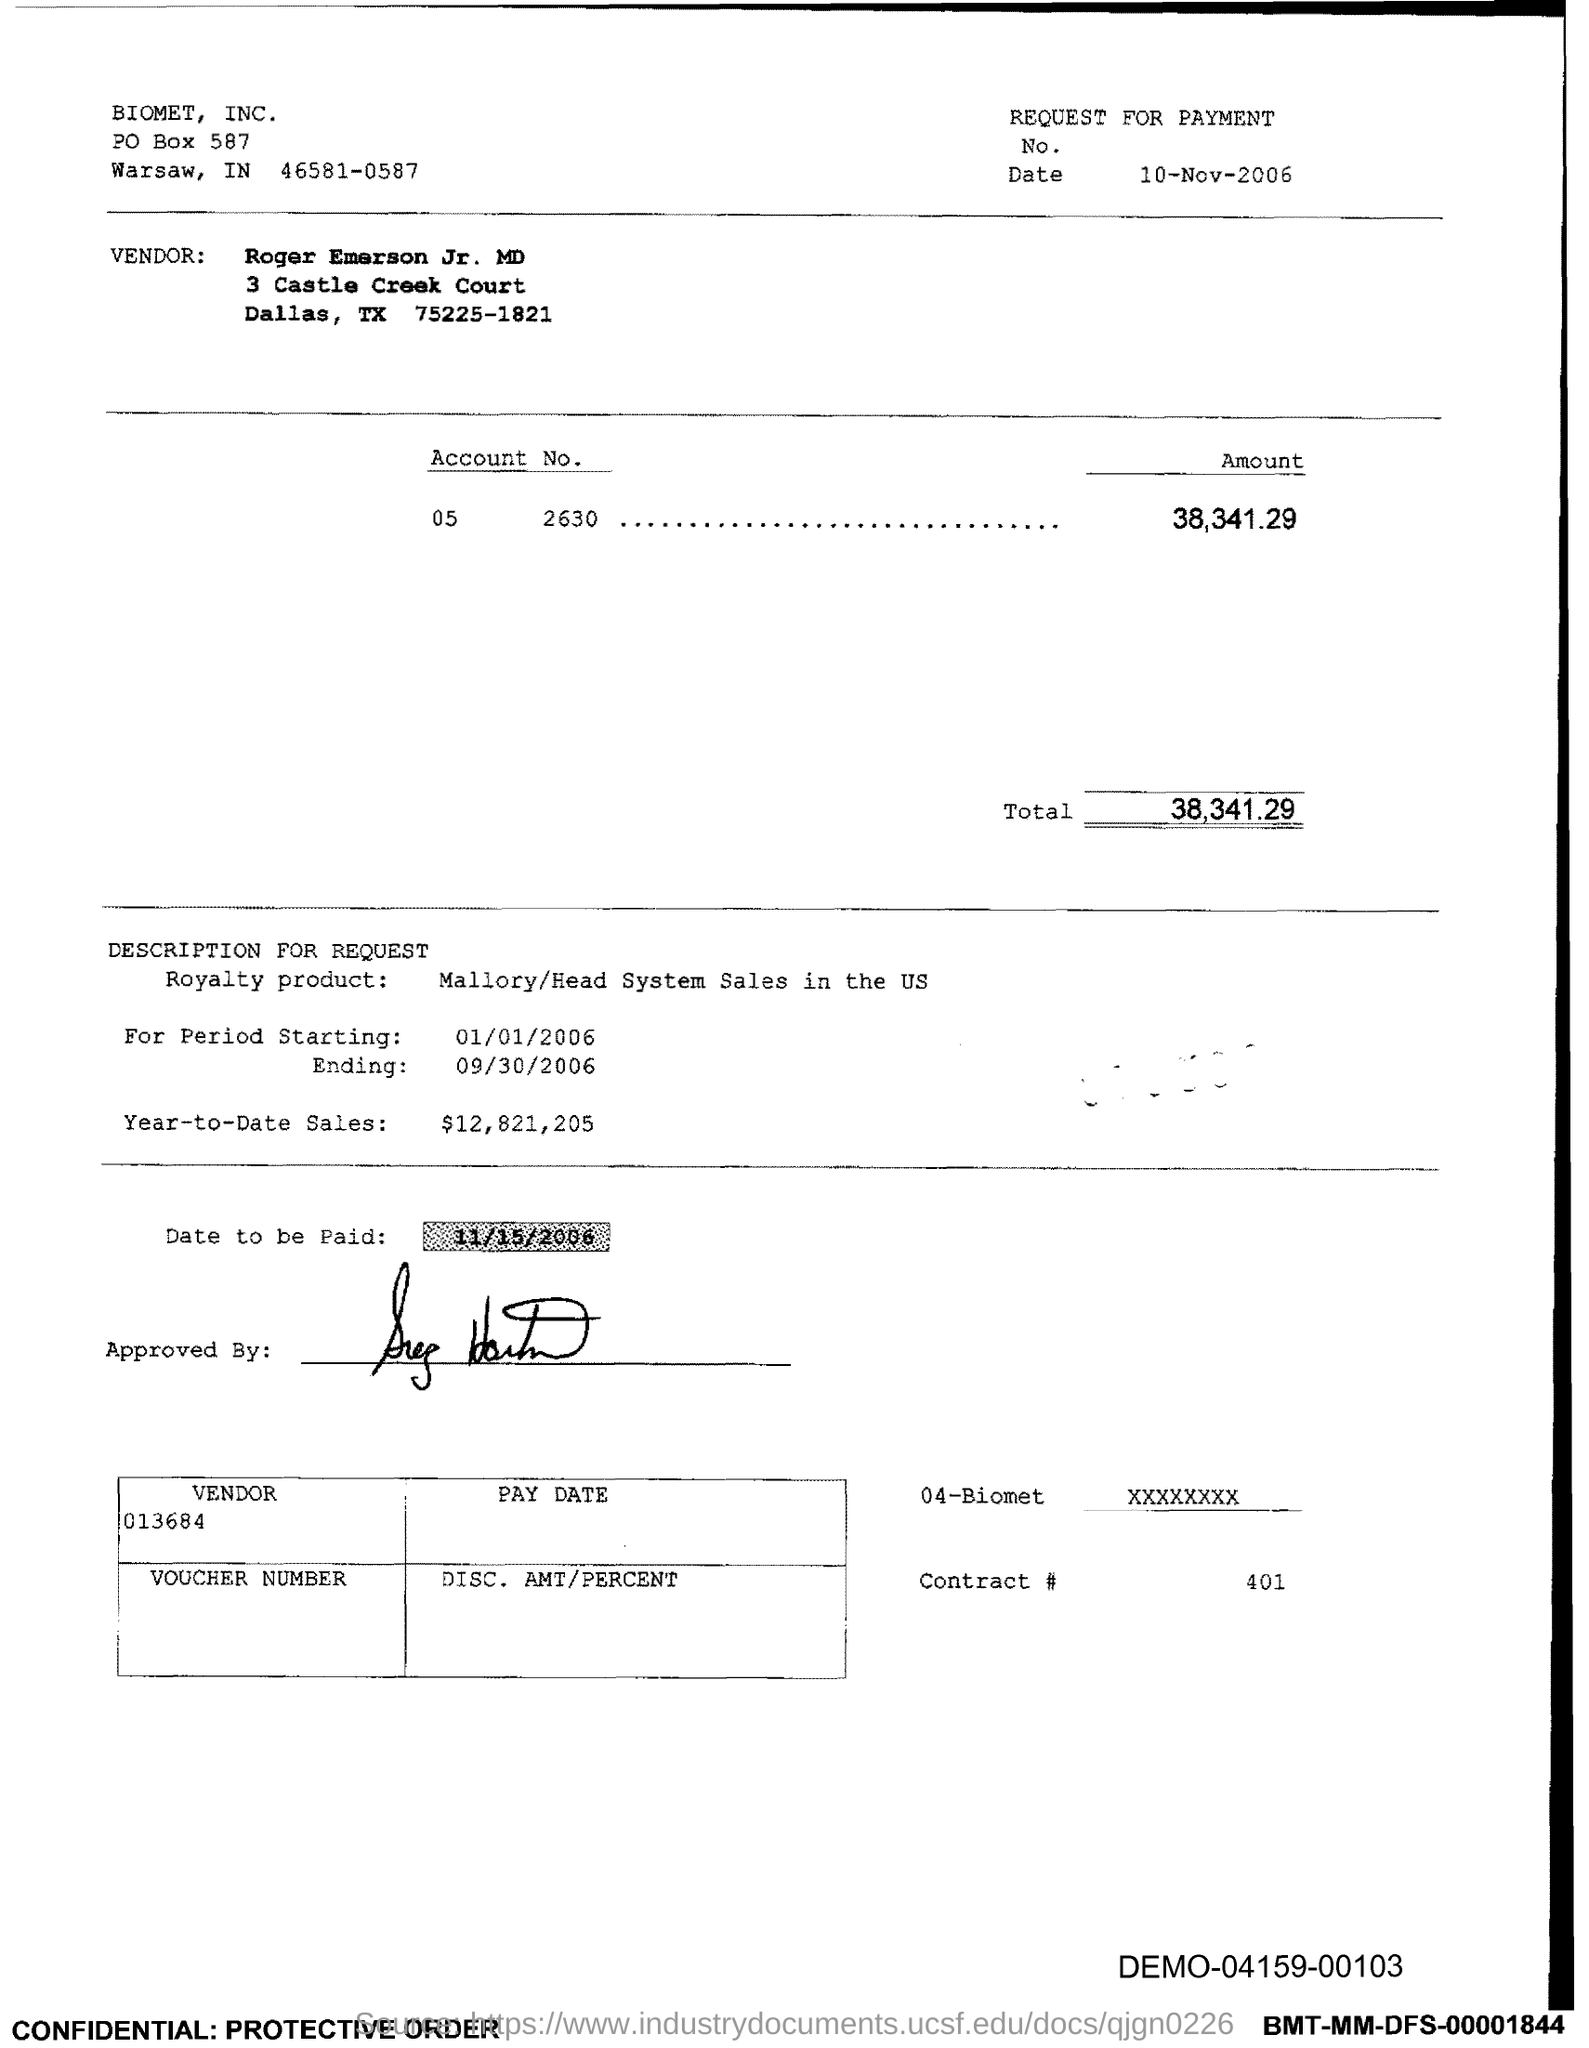Outline some significant characteristics in this image. The contract number is 401. The total amount is 38,341.29. 